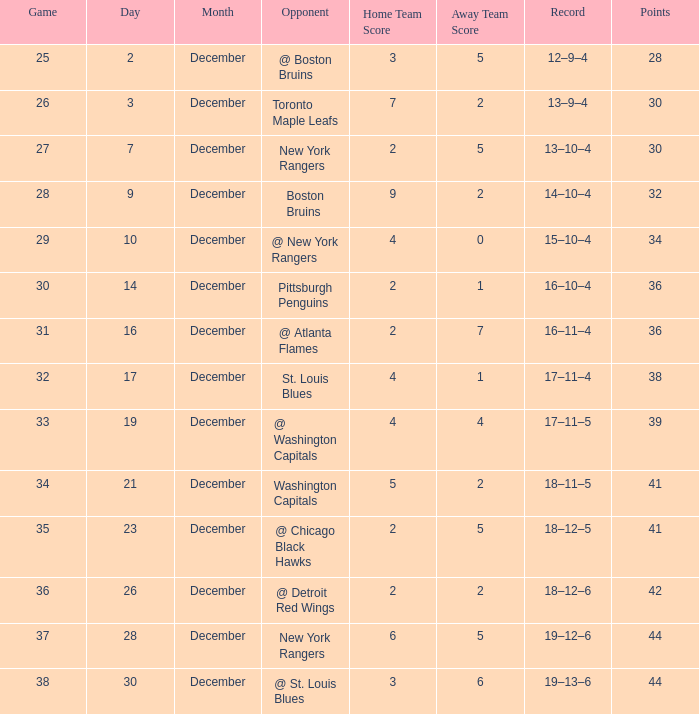Which Game has a Record of 14–10–4, and Points smaller than 32? None. 